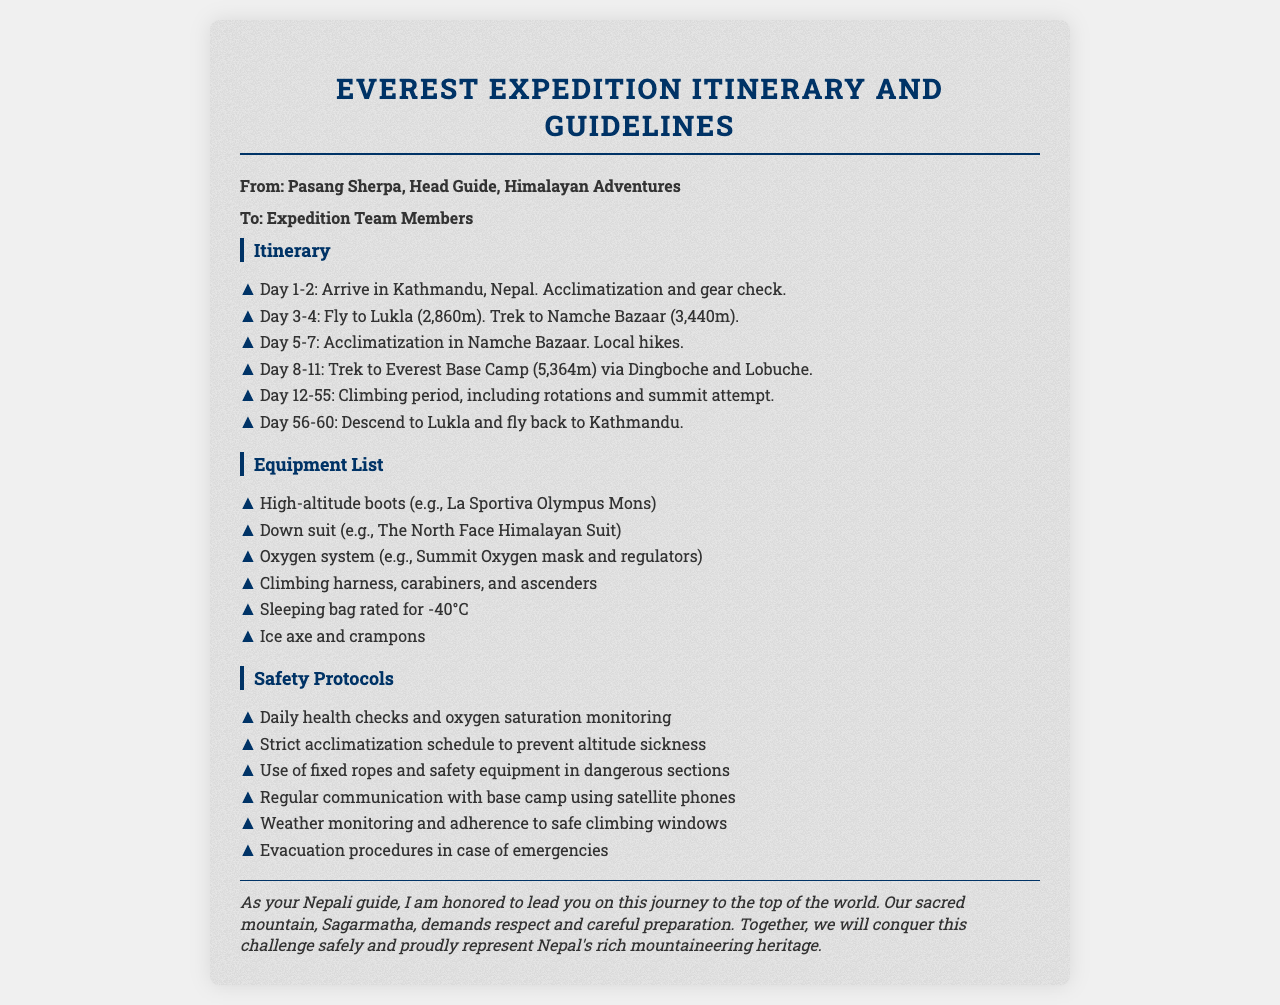What is the first destination in the itinerary? The first destination listed in the itinerary is Kathmandu, Nepal, for acclimatization and gear check.
Answer: Kathmandu How many days is the climbing period scheduled for? The climbing period is scheduled for a total of 44 days, from Day 12 to Day 55.
Answer: 44 Name one piece of equipment required for the expedition. A specific example of required equipment is the high-altitude boots.
Answer: High-altitude boots What safety protocol is in place to monitor climbers' health? One safety protocol mentioned is daily health checks and oxygen saturation monitoring.
Answer: Daily health checks How many days will the team spend in Namche Bazaar? The team will spend 3 days acclimatizing in Namche Bazaar according to the itinerary.
Answer: 3 days What are the last two days of the expedition focused on? The last two days are focused on descending to Lukla and flying back to Kathmandu.
Answer: Descending to Lukla and flying back to Kathmandu What is the weight rating for the sleeping bag required? The sleeping bag is required to be rated for -40°C to ensure adequate warmth.
Answer: -40°C Who is the sender of the fax? The sender of the fax is Pasang Sherpa, Head Guide of Himalayan Adventures.
Answer: Pasang Sherpa What is the maximum altitude of Everest Base Camp? The maximum altitude of Everest Base Camp is 5,364 meters.
Answer: 5,364 meters 